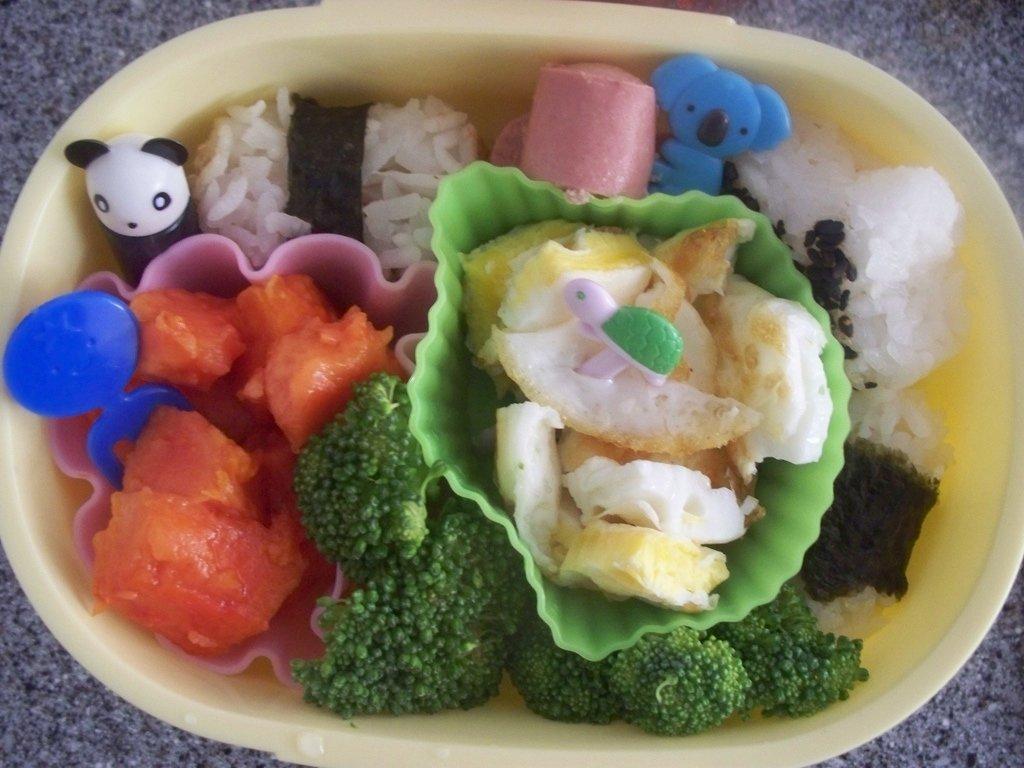In one or two sentences, can you explain what this image depicts? In the center of the image we can see a bowl which contains food is present on the floor. 